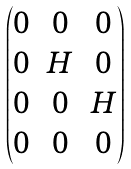<formula> <loc_0><loc_0><loc_500><loc_500>\begin{pmatrix} 0 & 0 & 0 \\ 0 & H & 0 \\ 0 & 0 & H \\ 0 & 0 & 0 \end{pmatrix}</formula> 